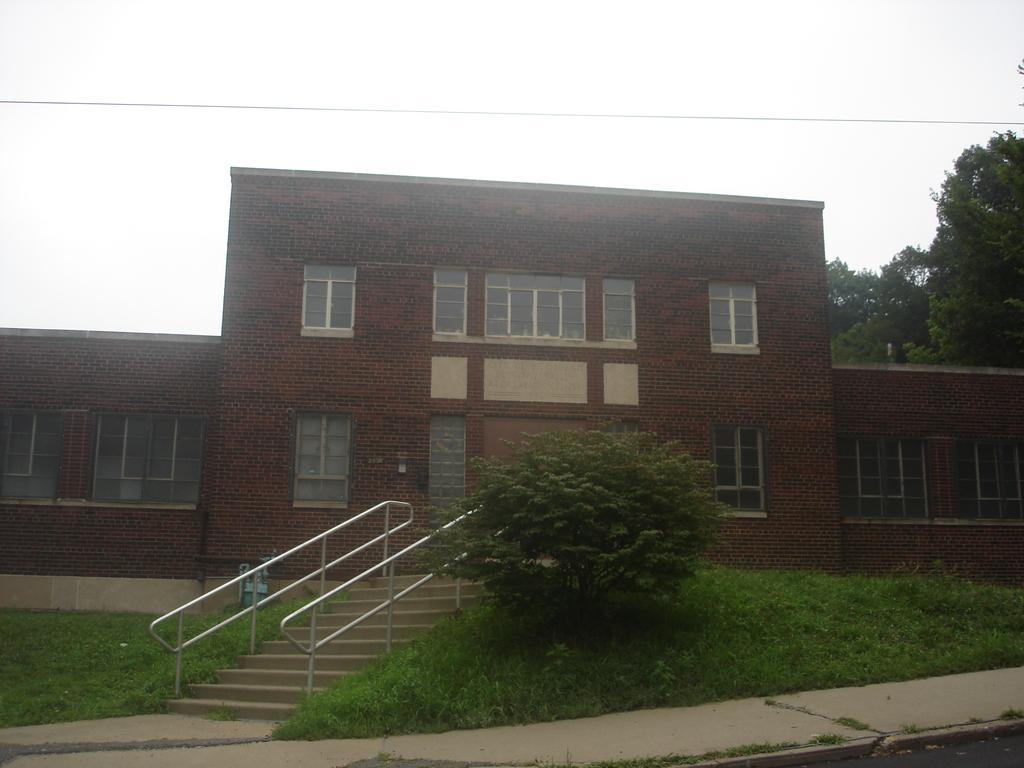Please provide a concise description of this image. In this image I can see grasses on the left side and in the middle I can see a house and on the back side there are trees. 